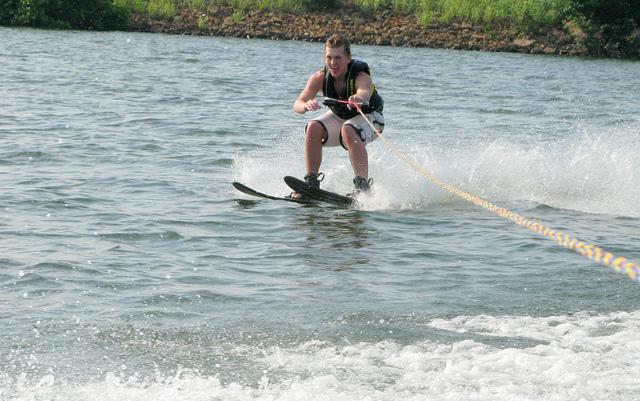What is he standing on?
Short answer required. Water skis. Is he on a wave?
Short answer required. No. Is there a ladder?
Be succinct. No. What is the color of the man's pants?
Concise answer only. White. What are these men doing?
Concise answer only. Water skiing. What activity is this man doing?
Be succinct. Water skiing. What are the three things in the background?
Keep it brief. Grass. What is the man holding?
Keep it brief. Rope. What activity is taking place in this picture?
Answer briefly. Water skiing. What is this person standing on?
Be succinct. Water skis. Does the man have facial hair?
Quick response, please. No. What color is his shorts?
Write a very short answer. White. Is he just learning to ski?
Be succinct. Yes. 